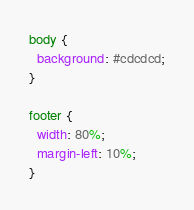Convert code to text. <code><loc_0><loc_0><loc_500><loc_500><_CSS_>body {
  background: #cdcdcd;
}

footer {
  width: 80%;
  margin-left: 10%;
}

</code> 